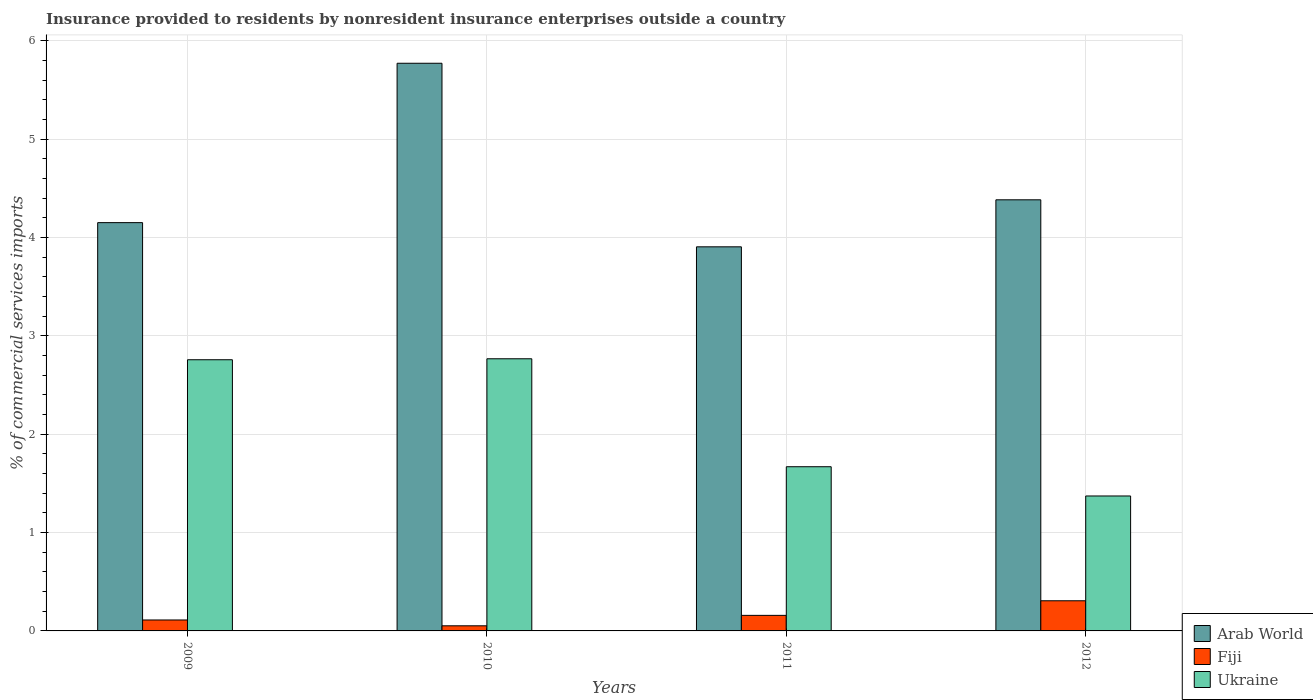How many different coloured bars are there?
Give a very brief answer. 3. How many bars are there on the 1st tick from the left?
Provide a succinct answer. 3. How many bars are there on the 4th tick from the right?
Your answer should be compact. 3. What is the Insurance provided to residents in Arab World in 2010?
Your response must be concise. 5.77. Across all years, what is the maximum Insurance provided to residents in Fiji?
Your answer should be very brief. 0.31. Across all years, what is the minimum Insurance provided to residents in Ukraine?
Provide a short and direct response. 1.37. In which year was the Insurance provided to residents in Fiji maximum?
Make the answer very short. 2012. In which year was the Insurance provided to residents in Fiji minimum?
Make the answer very short. 2010. What is the total Insurance provided to residents in Ukraine in the graph?
Keep it short and to the point. 8.56. What is the difference between the Insurance provided to residents in Ukraine in 2011 and that in 2012?
Your answer should be very brief. 0.3. What is the difference between the Insurance provided to residents in Fiji in 2011 and the Insurance provided to residents in Ukraine in 2012?
Your answer should be very brief. -1.21. What is the average Insurance provided to residents in Ukraine per year?
Your answer should be very brief. 2.14. In the year 2011, what is the difference between the Insurance provided to residents in Ukraine and Insurance provided to residents in Arab World?
Make the answer very short. -2.24. What is the ratio of the Insurance provided to residents in Ukraine in 2009 to that in 2011?
Keep it short and to the point. 1.65. Is the Insurance provided to residents in Fiji in 2009 less than that in 2010?
Keep it short and to the point. No. What is the difference between the highest and the second highest Insurance provided to residents in Fiji?
Ensure brevity in your answer.  0.15. What is the difference between the highest and the lowest Insurance provided to residents in Arab World?
Ensure brevity in your answer.  1.87. In how many years, is the Insurance provided to residents in Ukraine greater than the average Insurance provided to residents in Ukraine taken over all years?
Offer a terse response. 2. Is the sum of the Insurance provided to residents in Fiji in 2009 and 2012 greater than the maximum Insurance provided to residents in Ukraine across all years?
Give a very brief answer. No. What does the 3rd bar from the left in 2011 represents?
Give a very brief answer. Ukraine. What does the 1st bar from the right in 2012 represents?
Provide a succinct answer. Ukraine. Is it the case that in every year, the sum of the Insurance provided to residents in Fiji and Insurance provided to residents in Arab World is greater than the Insurance provided to residents in Ukraine?
Your answer should be compact. Yes. How many bars are there?
Provide a short and direct response. 12. Are all the bars in the graph horizontal?
Provide a short and direct response. No. What is the difference between two consecutive major ticks on the Y-axis?
Offer a very short reply. 1. Does the graph contain grids?
Make the answer very short. Yes. How many legend labels are there?
Your answer should be very brief. 3. How are the legend labels stacked?
Your answer should be compact. Vertical. What is the title of the graph?
Make the answer very short. Insurance provided to residents by nonresident insurance enterprises outside a country. What is the label or title of the Y-axis?
Your answer should be very brief. % of commercial services imports. What is the % of commercial services imports in Arab World in 2009?
Offer a terse response. 4.15. What is the % of commercial services imports in Fiji in 2009?
Give a very brief answer. 0.11. What is the % of commercial services imports of Ukraine in 2009?
Keep it short and to the point. 2.76. What is the % of commercial services imports of Arab World in 2010?
Your response must be concise. 5.77. What is the % of commercial services imports in Fiji in 2010?
Keep it short and to the point. 0.05. What is the % of commercial services imports in Ukraine in 2010?
Your answer should be compact. 2.77. What is the % of commercial services imports in Arab World in 2011?
Offer a terse response. 3.9. What is the % of commercial services imports of Fiji in 2011?
Your answer should be compact. 0.16. What is the % of commercial services imports of Ukraine in 2011?
Keep it short and to the point. 1.67. What is the % of commercial services imports of Arab World in 2012?
Your answer should be very brief. 4.38. What is the % of commercial services imports of Fiji in 2012?
Your response must be concise. 0.31. What is the % of commercial services imports of Ukraine in 2012?
Keep it short and to the point. 1.37. Across all years, what is the maximum % of commercial services imports of Arab World?
Give a very brief answer. 5.77. Across all years, what is the maximum % of commercial services imports of Fiji?
Provide a short and direct response. 0.31. Across all years, what is the maximum % of commercial services imports in Ukraine?
Offer a terse response. 2.77. Across all years, what is the minimum % of commercial services imports in Arab World?
Ensure brevity in your answer.  3.9. Across all years, what is the minimum % of commercial services imports in Fiji?
Your answer should be compact. 0.05. Across all years, what is the minimum % of commercial services imports of Ukraine?
Ensure brevity in your answer.  1.37. What is the total % of commercial services imports in Arab World in the graph?
Offer a terse response. 18.21. What is the total % of commercial services imports in Fiji in the graph?
Make the answer very short. 0.63. What is the total % of commercial services imports in Ukraine in the graph?
Your answer should be very brief. 8.56. What is the difference between the % of commercial services imports in Arab World in 2009 and that in 2010?
Your answer should be compact. -1.62. What is the difference between the % of commercial services imports of Fiji in 2009 and that in 2010?
Your answer should be compact. 0.06. What is the difference between the % of commercial services imports of Ukraine in 2009 and that in 2010?
Offer a terse response. -0.01. What is the difference between the % of commercial services imports in Arab World in 2009 and that in 2011?
Offer a terse response. 0.25. What is the difference between the % of commercial services imports of Fiji in 2009 and that in 2011?
Offer a terse response. -0.05. What is the difference between the % of commercial services imports of Ukraine in 2009 and that in 2011?
Your answer should be compact. 1.09. What is the difference between the % of commercial services imports of Arab World in 2009 and that in 2012?
Provide a succinct answer. -0.23. What is the difference between the % of commercial services imports in Fiji in 2009 and that in 2012?
Your answer should be compact. -0.2. What is the difference between the % of commercial services imports in Ukraine in 2009 and that in 2012?
Ensure brevity in your answer.  1.38. What is the difference between the % of commercial services imports of Arab World in 2010 and that in 2011?
Give a very brief answer. 1.87. What is the difference between the % of commercial services imports in Fiji in 2010 and that in 2011?
Your answer should be very brief. -0.11. What is the difference between the % of commercial services imports of Ukraine in 2010 and that in 2011?
Offer a terse response. 1.1. What is the difference between the % of commercial services imports of Arab World in 2010 and that in 2012?
Ensure brevity in your answer.  1.39. What is the difference between the % of commercial services imports in Fiji in 2010 and that in 2012?
Give a very brief answer. -0.25. What is the difference between the % of commercial services imports of Ukraine in 2010 and that in 2012?
Give a very brief answer. 1.39. What is the difference between the % of commercial services imports in Arab World in 2011 and that in 2012?
Your answer should be compact. -0.48. What is the difference between the % of commercial services imports in Fiji in 2011 and that in 2012?
Offer a terse response. -0.15. What is the difference between the % of commercial services imports of Ukraine in 2011 and that in 2012?
Offer a terse response. 0.3. What is the difference between the % of commercial services imports of Arab World in 2009 and the % of commercial services imports of Fiji in 2010?
Offer a very short reply. 4.1. What is the difference between the % of commercial services imports of Arab World in 2009 and the % of commercial services imports of Ukraine in 2010?
Offer a very short reply. 1.38. What is the difference between the % of commercial services imports of Fiji in 2009 and the % of commercial services imports of Ukraine in 2010?
Offer a terse response. -2.66. What is the difference between the % of commercial services imports in Arab World in 2009 and the % of commercial services imports in Fiji in 2011?
Your response must be concise. 3.99. What is the difference between the % of commercial services imports of Arab World in 2009 and the % of commercial services imports of Ukraine in 2011?
Provide a short and direct response. 2.48. What is the difference between the % of commercial services imports of Fiji in 2009 and the % of commercial services imports of Ukraine in 2011?
Your answer should be compact. -1.56. What is the difference between the % of commercial services imports of Arab World in 2009 and the % of commercial services imports of Fiji in 2012?
Offer a terse response. 3.84. What is the difference between the % of commercial services imports of Arab World in 2009 and the % of commercial services imports of Ukraine in 2012?
Provide a succinct answer. 2.78. What is the difference between the % of commercial services imports in Fiji in 2009 and the % of commercial services imports in Ukraine in 2012?
Your answer should be compact. -1.26. What is the difference between the % of commercial services imports in Arab World in 2010 and the % of commercial services imports in Fiji in 2011?
Offer a terse response. 5.61. What is the difference between the % of commercial services imports of Arab World in 2010 and the % of commercial services imports of Ukraine in 2011?
Offer a very short reply. 4.1. What is the difference between the % of commercial services imports of Fiji in 2010 and the % of commercial services imports of Ukraine in 2011?
Make the answer very short. -1.62. What is the difference between the % of commercial services imports in Arab World in 2010 and the % of commercial services imports in Fiji in 2012?
Provide a short and direct response. 5.46. What is the difference between the % of commercial services imports of Arab World in 2010 and the % of commercial services imports of Ukraine in 2012?
Provide a succinct answer. 4.4. What is the difference between the % of commercial services imports of Fiji in 2010 and the % of commercial services imports of Ukraine in 2012?
Provide a short and direct response. -1.32. What is the difference between the % of commercial services imports in Arab World in 2011 and the % of commercial services imports in Fiji in 2012?
Your answer should be very brief. 3.6. What is the difference between the % of commercial services imports of Arab World in 2011 and the % of commercial services imports of Ukraine in 2012?
Offer a very short reply. 2.53. What is the difference between the % of commercial services imports in Fiji in 2011 and the % of commercial services imports in Ukraine in 2012?
Your answer should be very brief. -1.21. What is the average % of commercial services imports of Arab World per year?
Make the answer very short. 4.55. What is the average % of commercial services imports in Fiji per year?
Give a very brief answer. 0.16. What is the average % of commercial services imports in Ukraine per year?
Make the answer very short. 2.14. In the year 2009, what is the difference between the % of commercial services imports in Arab World and % of commercial services imports in Fiji?
Give a very brief answer. 4.04. In the year 2009, what is the difference between the % of commercial services imports in Arab World and % of commercial services imports in Ukraine?
Your response must be concise. 1.39. In the year 2009, what is the difference between the % of commercial services imports in Fiji and % of commercial services imports in Ukraine?
Your answer should be compact. -2.65. In the year 2010, what is the difference between the % of commercial services imports in Arab World and % of commercial services imports in Fiji?
Provide a succinct answer. 5.72. In the year 2010, what is the difference between the % of commercial services imports in Arab World and % of commercial services imports in Ukraine?
Provide a short and direct response. 3. In the year 2010, what is the difference between the % of commercial services imports of Fiji and % of commercial services imports of Ukraine?
Provide a short and direct response. -2.71. In the year 2011, what is the difference between the % of commercial services imports of Arab World and % of commercial services imports of Fiji?
Offer a terse response. 3.75. In the year 2011, what is the difference between the % of commercial services imports in Arab World and % of commercial services imports in Ukraine?
Your response must be concise. 2.24. In the year 2011, what is the difference between the % of commercial services imports of Fiji and % of commercial services imports of Ukraine?
Give a very brief answer. -1.51. In the year 2012, what is the difference between the % of commercial services imports in Arab World and % of commercial services imports in Fiji?
Offer a very short reply. 4.08. In the year 2012, what is the difference between the % of commercial services imports in Arab World and % of commercial services imports in Ukraine?
Provide a succinct answer. 3.01. In the year 2012, what is the difference between the % of commercial services imports in Fiji and % of commercial services imports in Ukraine?
Give a very brief answer. -1.07. What is the ratio of the % of commercial services imports in Arab World in 2009 to that in 2010?
Keep it short and to the point. 0.72. What is the ratio of the % of commercial services imports in Fiji in 2009 to that in 2010?
Keep it short and to the point. 2.14. What is the ratio of the % of commercial services imports of Ukraine in 2009 to that in 2010?
Offer a very short reply. 1. What is the ratio of the % of commercial services imports of Arab World in 2009 to that in 2011?
Your response must be concise. 1.06. What is the ratio of the % of commercial services imports of Fiji in 2009 to that in 2011?
Your response must be concise. 0.7. What is the ratio of the % of commercial services imports in Ukraine in 2009 to that in 2011?
Make the answer very short. 1.65. What is the ratio of the % of commercial services imports in Arab World in 2009 to that in 2012?
Ensure brevity in your answer.  0.95. What is the ratio of the % of commercial services imports in Fiji in 2009 to that in 2012?
Your response must be concise. 0.36. What is the ratio of the % of commercial services imports of Ukraine in 2009 to that in 2012?
Make the answer very short. 2.01. What is the ratio of the % of commercial services imports of Arab World in 2010 to that in 2011?
Offer a very short reply. 1.48. What is the ratio of the % of commercial services imports of Fiji in 2010 to that in 2011?
Offer a very short reply. 0.33. What is the ratio of the % of commercial services imports in Ukraine in 2010 to that in 2011?
Your answer should be very brief. 1.66. What is the ratio of the % of commercial services imports in Arab World in 2010 to that in 2012?
Offer a terse response. 1.32. What is the ratio of the % of commercial services imports of Fiji in 2010 to that in 2012?
Your answer should be very brief. 0.17. What is the ratio of the % of commercial services imports in Ukraine in 2010 to that in 2012?
Make the answer very short. 2.02. What is the ratio of the % of commercial services imports of Arab World in 2011 to that in 2012?
Provide a short and direct response. 0.89. What is the ratio of the % of commercial services imports in Fiji in 2011 to that in 2012?
Keep it short and to the point. 0.52. What is the ratio of the % of commercial services imports in Ukraine in 2011 to that in 2012?
Make the answer very short. 1.22. What is the difference between the highest and the second highest % of commercial services imports in Arab World?
Your answer should be compact. 1.39. What is the difference between the highest and the second highest % of commercial services imports of Fiji?
Make the answer very short. 0.15. What is the difference between the highest and the second highest % of commercial services imports of Ukraine?
Your answer should be compact. 0.01. What is the difference between the highest and the lowest % of commercial services imports of Arab World?
Give a very brief answer. 1.87. What is the difference between the highest and the lowest % of commercial services imports of Fiji?
Make the answer very short. 0.25. What is the difference between the highest and the lowest % of commercial services imports in Ukraine?
Provide a succinct answer. 1.39. 